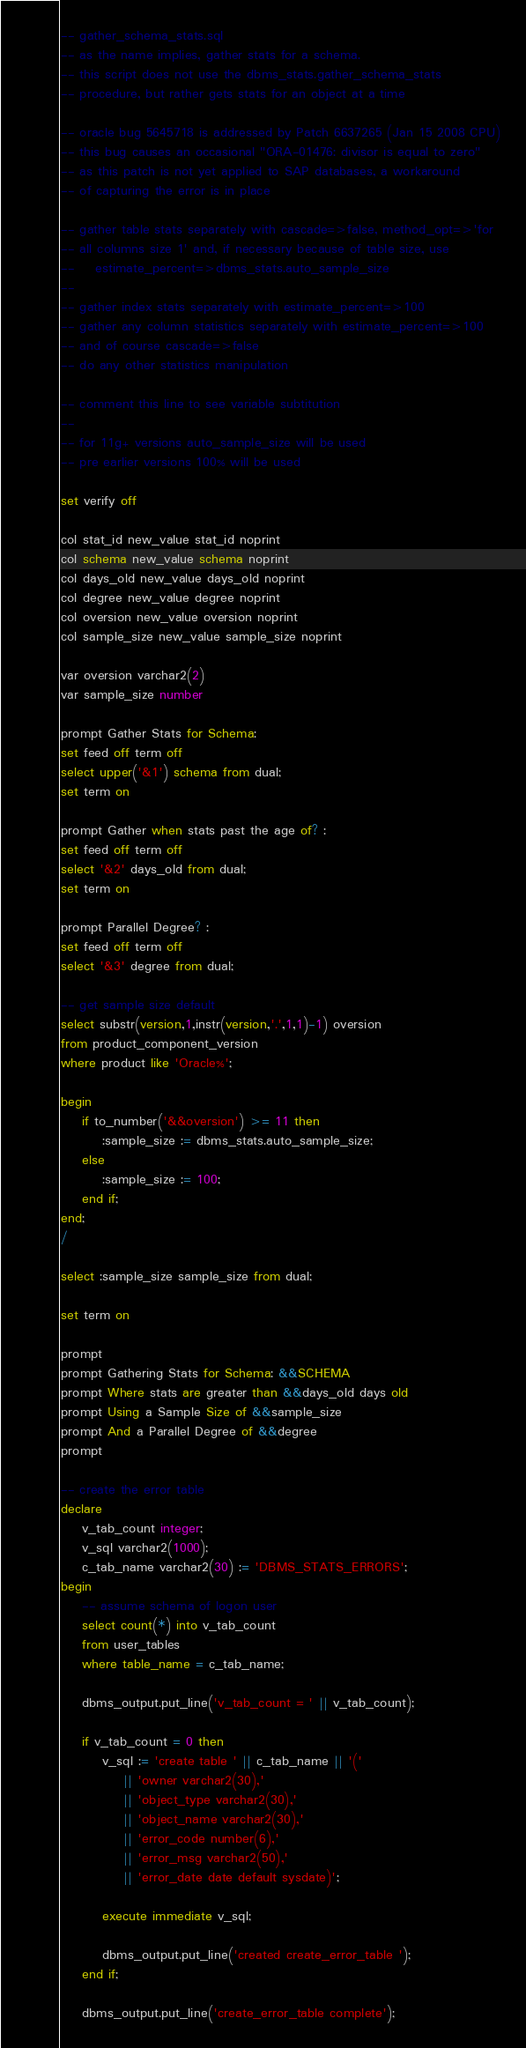<code> <loc_0><loc_0><loc_500><loc_500><_SQL_>

-- gather_schema_stats.sql
-- as the name implies, gather stats for a schema.
-- this script does not use the dbms_stats.gather_schema_stats 
-- procedure, but rather gets stats for an object at a time

-- oracle bug 5645718 is addressed by Patch 6637265 (Jan 15 2008 CPU)
-- this bug causes an occasional "ORA-01476: divisor is equal to zero"
-- as this patch is not yet applied to SAP databases, a workaround
-- of capturing the error is in place

-- gather table stats separately with cascade=>false, method_opt=>'for
-- all columns size 1' and, if necessary because of table size, use
--    estimate_percent=>dbms_stats.auto_sample_size
--
-- gather index stats separately with estimate_percent=>100
-- gather any column statistics separately with estimate_percent=>100
-- and of course cascade=>false
-- do any other statistics manipulation

-- comment this line to see variable subtitution
--
-- for 11g+ versions auto_sample_size will be used
-- pre earlier versions 100% will be used

set verify off

col stat_id new_value stat_id noprint
col schema new_value schema noprint
col days_old new_value days_old noprint
col degree new_value degree noprint
col oversion new_value oversion noprint
col sample_size new_value sample_size noprint

var oversion varchar2(2)
var sample_size number

prompt Gather Stats for Schema:
set feed off term off
select upper('&1') schema from dual;
set term on

prompt Gather when stats past the age of? :
set feed off term off
select '&2' days_old from dual;
set term on

prompt Parallel Degree? :
set feed off term off
select '&3' degree from dual;

-- get sample size default
select substr(version,1,instr(version,'.',1,1)-1) oversion
from product_component_version
where product like 'Oracle%';

begin
	if to_number('&&oversion') >= 11 then
		:sample_size := dbms_stats.auto_sample_size;
	else
		:sample_size := 100;
	end if;
end;
/

select :sample_size sample_size from dual;

set term on

prompt
prompt Gathering Stats for Schema: &&SCHEMA
prompt Where stats are greater than &&days_old days old
prompt Using a Sample Size of &&sample_size
prompt And a Parallel Degree of &&degree
prompt

-- create the error table
declare
	v_tab_count integer;
	v_sql varchar2(1000);
	c_tab_name varchar2(30) := 'DBMS_STATS_ERRORS';
begin
	-- assume schema of logon user
	select count(*) into v_tab_count
	from user_tables
	where table_name = c_tab_name;

	dbms_output.put_line('v_tab_count = ' || v_tab_count);

	if v_tab_count = 0 then
		v_sql := 'create table ' || c_tab_name || '('
			|| 'owner varchar2(30),'
			|| 'object_type varchar2(30),'
			|| 'object_name varchar2(30),'
			|| 'error_code number(6),'
			|| 'error_msg varchar2(50),'
			|| 'error_date date default sysdate)';

		execute immediate v_sql;
		
		dbms_output.put_line('created create_error_table ');
	end if;
		
	dbms_output.put_line('create_error_table complete');</code> 